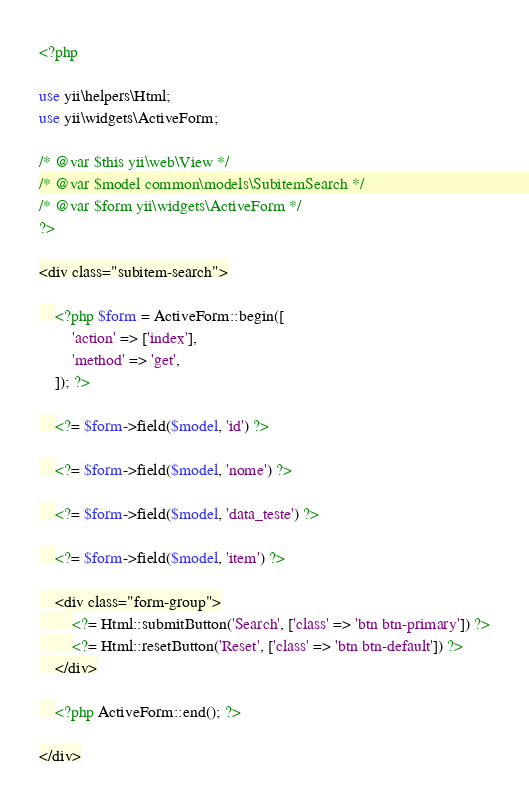Convert code to text. <code><loc_0><loc_0><loc_500><loc_500><_PHP_><?php

use yii\helpers\Html;
use yii\widgets\ActiveForm;

/* @var $this yii\web\View */
/* @var $model common\models\SubitemSearch */
/* @var $form yii\widgets\ActiveForm */
?>

<div class="subitem-search">

    <?php $form = ActiveForm::begin([
        'action' => ['index'],
        'method' => 'get',
    ]); ?>

    <?= $form->field($model, 'id') ?>

    <?= $form->field($model, 'nome') ?>

    <?= $form->field($model, 'data_teste') ?>

    <?= $form->field($model, 'item') ?>

    <div class="form-group">
        <?= Html::submitButton('Search', ['class' => 'btn btn-primary']) ?>
        <?= Html::resetButton('Reset', ['class' => 'btn btn-default']) ?>
    </div>

    <?php ActiveForm::end(); ?>

</div>
</code> 